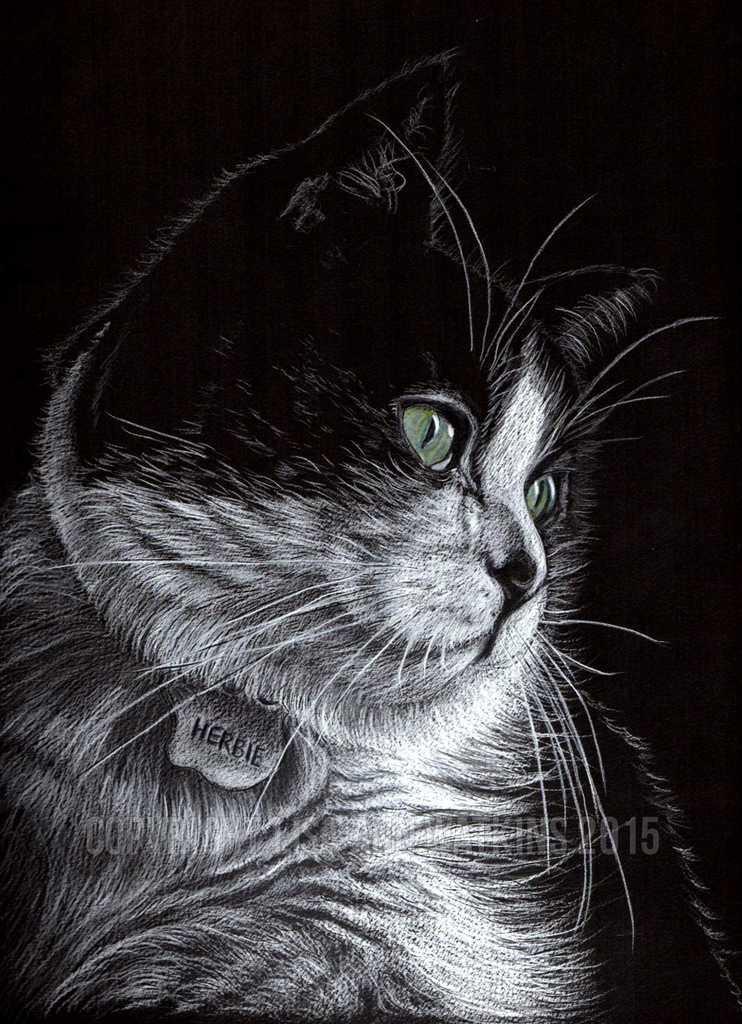Could you give a brief overview of what you see in this image? In the center of the image we can see drawing of a cat. 